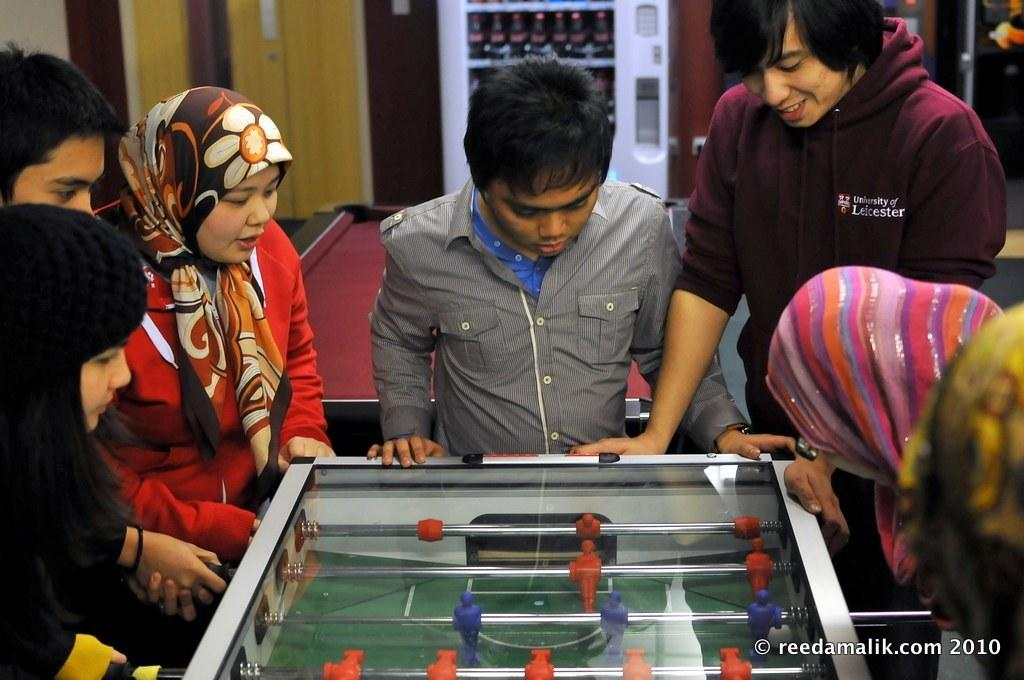What activity are the people in the image engaged in? The people in the image are playing a game. How many women are present in the image? There are four women in the image. How many boys are present in the image? There are three boys in the image. What type of space-themed game are the people playing in the image? There is no indication of a space-themed game in the image; the people are simply playing a game. Can you see any deer in the image? There are no deer present in the image. 